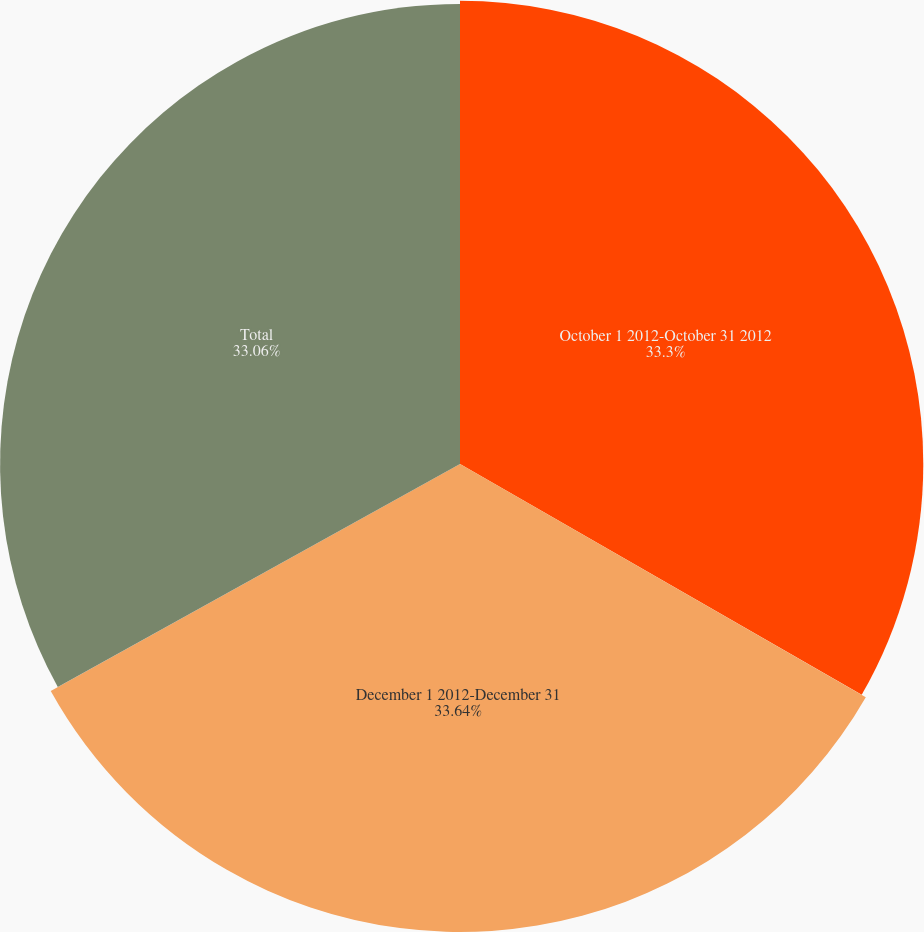<chart> <loc_0><loc_0><loc_500><loc_500><pie_chart><fcel>October 1 2012-October 31 2012<fcel>December 1 2012-December 31<fcel>Total<nl><fcel>33.3%<fcel>33.64%<fcel>33.06%<nl></chart> 